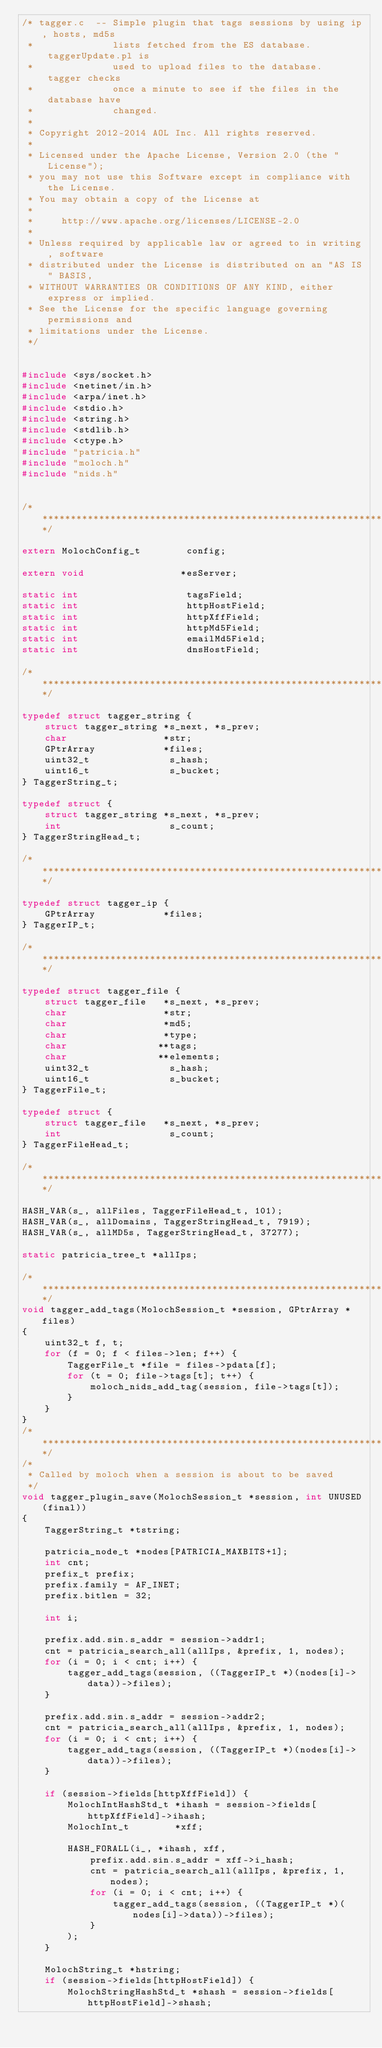<code> <loc_0><loc_0><loc_500><loc_500><_C_>/* tagger.c  -- Simple plugin that tags sessions by using ip, hosts, md5s
 *              lists fetched from the ES database.  taggerUpdate.pl is
 *              used to upload files to the database.  tagger checks
 *              once a minute to see if the files in the database have 
 *              changed.
 *     
 * Copyright 2012-2014 AOL Inc. All rights reserved.
 * 
 * Licensed under the Apache License, Version 2.0 (the "License");
 * you may not use this Software except in compliance with the License.
 * You may obtain a copy of the License at
 * 
 *     http://www.apache.org/licenses/LICENSE-2.0
 * 
 * Unless required by applicable law or agreed to in writing, software
 * distributed under the License is distributed on an "AS IS" BASIS,
 * WITHOUT WARRANTIES OR CONDITIONS OF ANY KIND, either express or implied.
 * See the License for the specific language governing permissions and
 * limitations under the License.
 */


#include <sys/socket.h>
#include <netinet/in.h>
#include <arpa/inet.h>
#include <stdio.h>
#include <string.h>
#include <stdlib.h>
#include <ctype.h>
#include "patricia.h"
#include "moloch.h"
#include "nids.h"


/******************************************************************************/

extern MolochConfig_t        config;

extern void                 *esServer;

static int                   tagsField;
static int                   httpHostField;
static int                   httpXffField;
static int                   httpMd5Field;
static int                   emailMd5Field;
static int                   dnsHostField;

/******************************************************************************/

typedef struct tagger_string {
    struct tagger_string *s_next, *s_prev;
    char                 *str;
    GPtrArray            *files;
    uint32_t              s_hash;
    uint16_t              s_bucket;
} TaggerString_t;

typedef struct {
    struct tagger_string *s_next, *s_prev;
    int                   s_count;
} TaggerStringHead_t;

/******************************************************************************/

typedef struct tagger_ip {
    GPtrArray            *files;
} TaggerIP_t;

/******************************************************************************/

typedef struct tagger_file {
    struct tagger_file   *s_next, *s_prev;
    char                 *str;
    char                 *md5;
    char                 *type;
    char                **tags;
    char                **elements;
    uint32_t              s_hash;
    uint16_t              s_bucket;
} TaggerFile_t;

typedef struct {
    struct tagger_file   *s_next, *s_prev;
    int                   s_count;
} TaggerFileHead_t;

/******************************************************************************/

HASH_VAR(s_, allFiles, TaggerFileHead_t, 101);
HASH_VAR(s_, allDomains, TaggerStringHead_t, 7919);
HASH_VAR(s_, allMD5s, TaggerStringHead_t, 37277);

static patricia_tree_t *allIps;

/******************************************************************************/
void tagger_add_tags(MolochSession_t *session, GPtrArray *files)
{
    uint32_t f, t;
    for (f = 0; f < files->len; f++) {
        TaggerFile_t *file = files->pdata[f];
        for (t = 0; file->tags[t]; t++) {
            moloch_nids_add_tag(session, file->tags[t]);
        }
    }
}
/******************************************************************************/
/* 
 * Called by moloch when a session is about to be saved
 */
void tagger_plugin_save(MolochSession_t *session, int UNUSED(final))
{
    TaggerString_t *tstring;

    patricia_node_t *nodes[PATRICIA_MAXBITS+1];
    int cnt;  
    prefix_t prefix;
    prefix.family = AF_INET;
    prefix.bitlen = 32;

    int i;

    prefix.add.sin.s_addr = session->addr1;
    cnt = patricia_search_all(allIps, &prefix, 1, nodes);
    for (i = 0; i < cnt; i++) {
        tagger_add_tags(session, ((TaggerIP_t *)(nodes[i]->data))->files);
    }

    prefix.add.sin.s_addr = session->addr2;
    cnt = patricia_search_all(allIps, &prefix, 1, nodes);
    for (i = 0; i < cnt; i++) {
        tagger_add_tags(session, ((TaggerIP_t *)(nodes[i]->data))->files);
    }

    if (session->fields[httpXffField]) {
        MolochIntHashStd_t *ihash = session->fields[httpXffField]->ihash;
        MolochInt_t        *xff;

        HASH_FORALL(i_, *ihash, xff, 
            prefix.add.sin.s_addr = xff->i_hash;
            cnt = patricia_search_all(allIps, &prefix, 1, nodes);
            for (i = 0; i < cnt; i++) {
                tagger_add_tags(session, ((TaggerIP_t *)(nodes[i]->data))->files);
            }
        );
    }

    MolochString_t *hstring;
    if (session->fields[httpHostField]) {
        MolochStringHashStd_t *shash = session->fields[httpHostField]->shash;</code> 